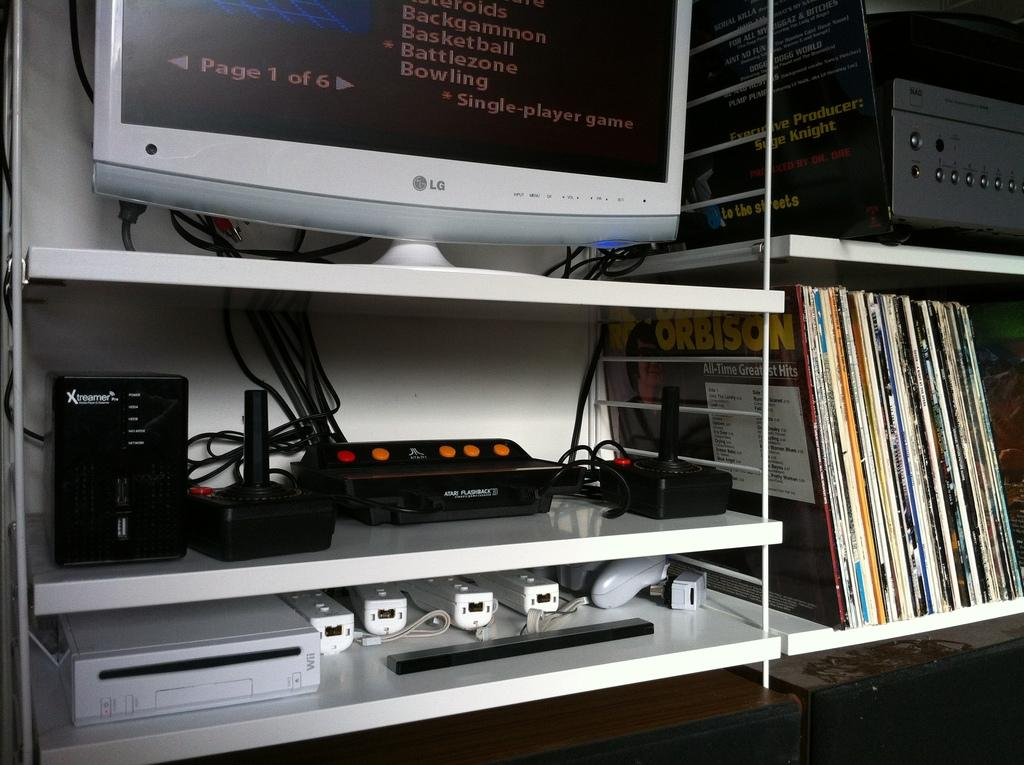Provide a one-sentence caption for the provided image. Roy Orbison's All Time Greatest Hits is among the records on the shelf unit. 